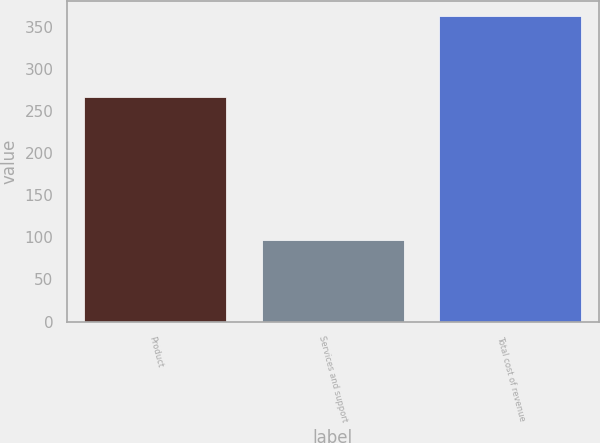Convert chart to OTSL. <chart><loc_0><loc_0><loc_500><loc_500><bar_chart><fcel>Product<fcel>Services and support<fcel>Total cost of revenue<nl><fcel>266.4<fcel>96.2<fcel>362.6<nl></chart> 